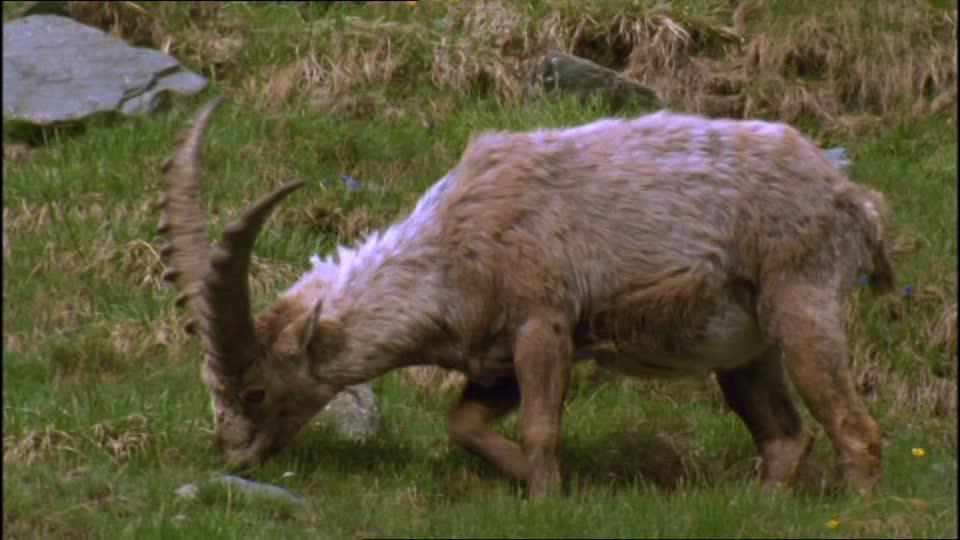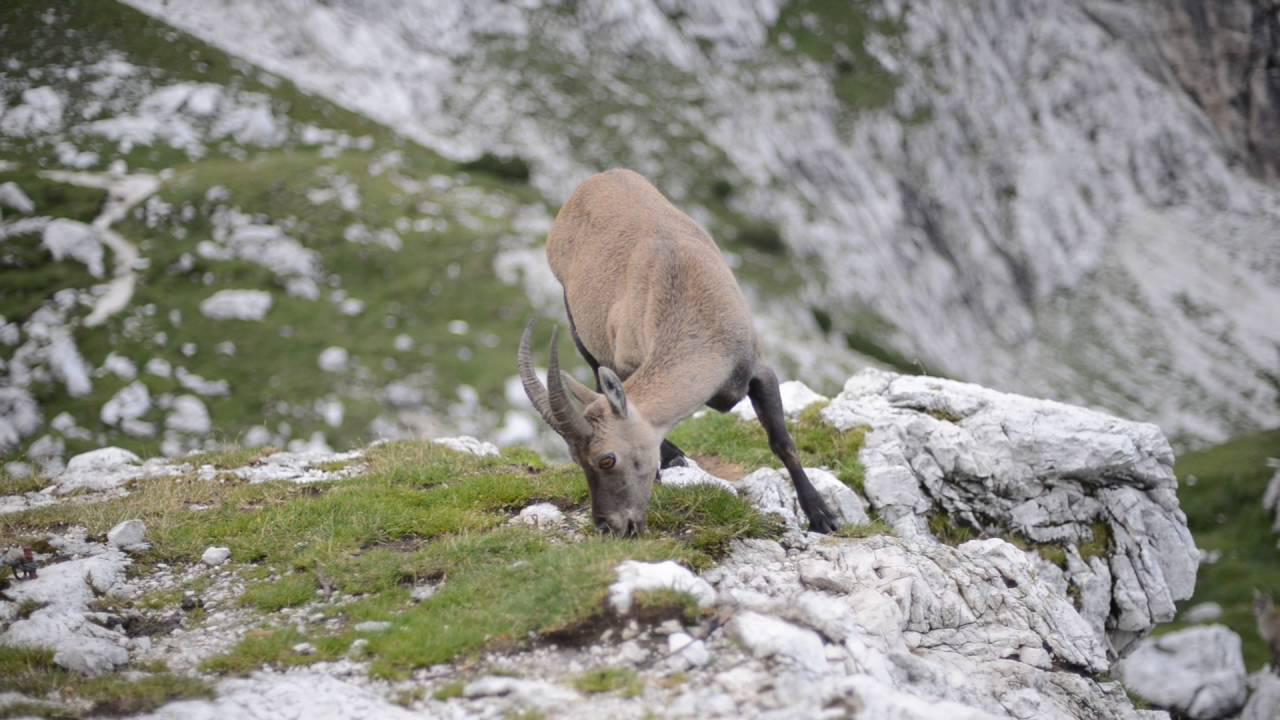The first image is the image on the left, the second image is the image on the right. For the images displayed, is the sentence "Each ram on the left has it's nose down sniffing an object." factually correct? Answer yes or no. Yes. 